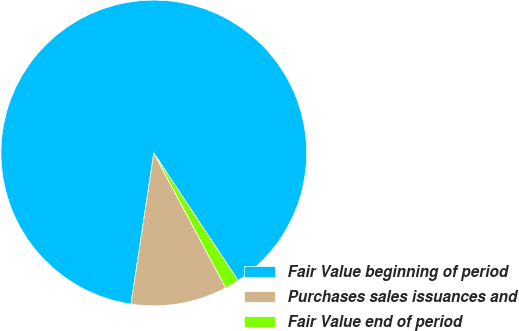Convert chart to OTSL. <chart><loc_0><loc_0><loc_500><loc_500><pie_chart><fcel>Fair Value beginning of period<fcel>Purchases sales issuances and<fcel>Fair Value end of period<nl><fcel>88.31%<fcel>10.18%<fcel>1.5%<nl></chart> 